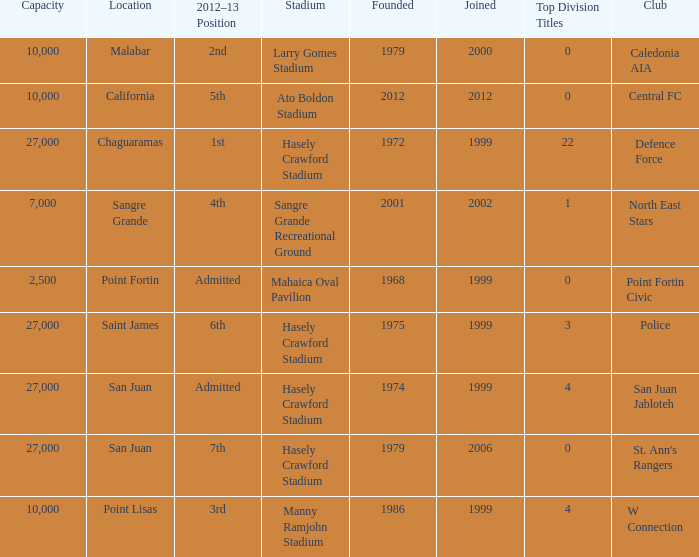Can you give me this table as a dict? {'header': ['Capacity', 'Location', '2012–13 Position', 'Stadium', 'Founded', 'Joined', 'Top Division Titles', 'Club'], 'rows': [['10,000', 'Malabar', '2nd', 'Larry Gomes Stadium', '1979', '2000', '0', 'Caledonia AIA'], ['10,000', 'California', '5th', 'Ato Boldon Stadium', '2012', '2012', '0', 'Central FC'], ['27,000', 'Chaguaramas', '1st', 'Hasely Crawford Stadium', '1972', '1999', '22', 'Defence Force'], ['7,000', 'Sangre Grande', '4th', 'Sangre Grande Recreational Ground', '2001', '2002', '1', 'North East Stars'], ['2,500', 'Point Fortin', 'Admitted', 'Mahaica Oval Pavilion', '1968', '1999', '0', 'Point Fortin Civic'], ['27,000', 'Saint James', '6th', 'Hasely Crawford Stadium', '1975', '1999', '3', 'Police'], ['27,000', 'San Juan', 'Admitted', 'Hasely Crawford Stadium', '1974', '1999', '4', 'San Juan Jabloteh'], ['27,000', 'San Juan', '7th', 'Hasely Crawford Stadium', '1979', '2006', '0', "St. Ann's Rangers"], ['10,000', 'Point Lisas', '3rd', 'Manny Ramjohn Stadium', '1986', '1999', '4', 'W Connection']]} Which stadium was used for the North East Stars club? Sangre Grande Recreational Ground. 